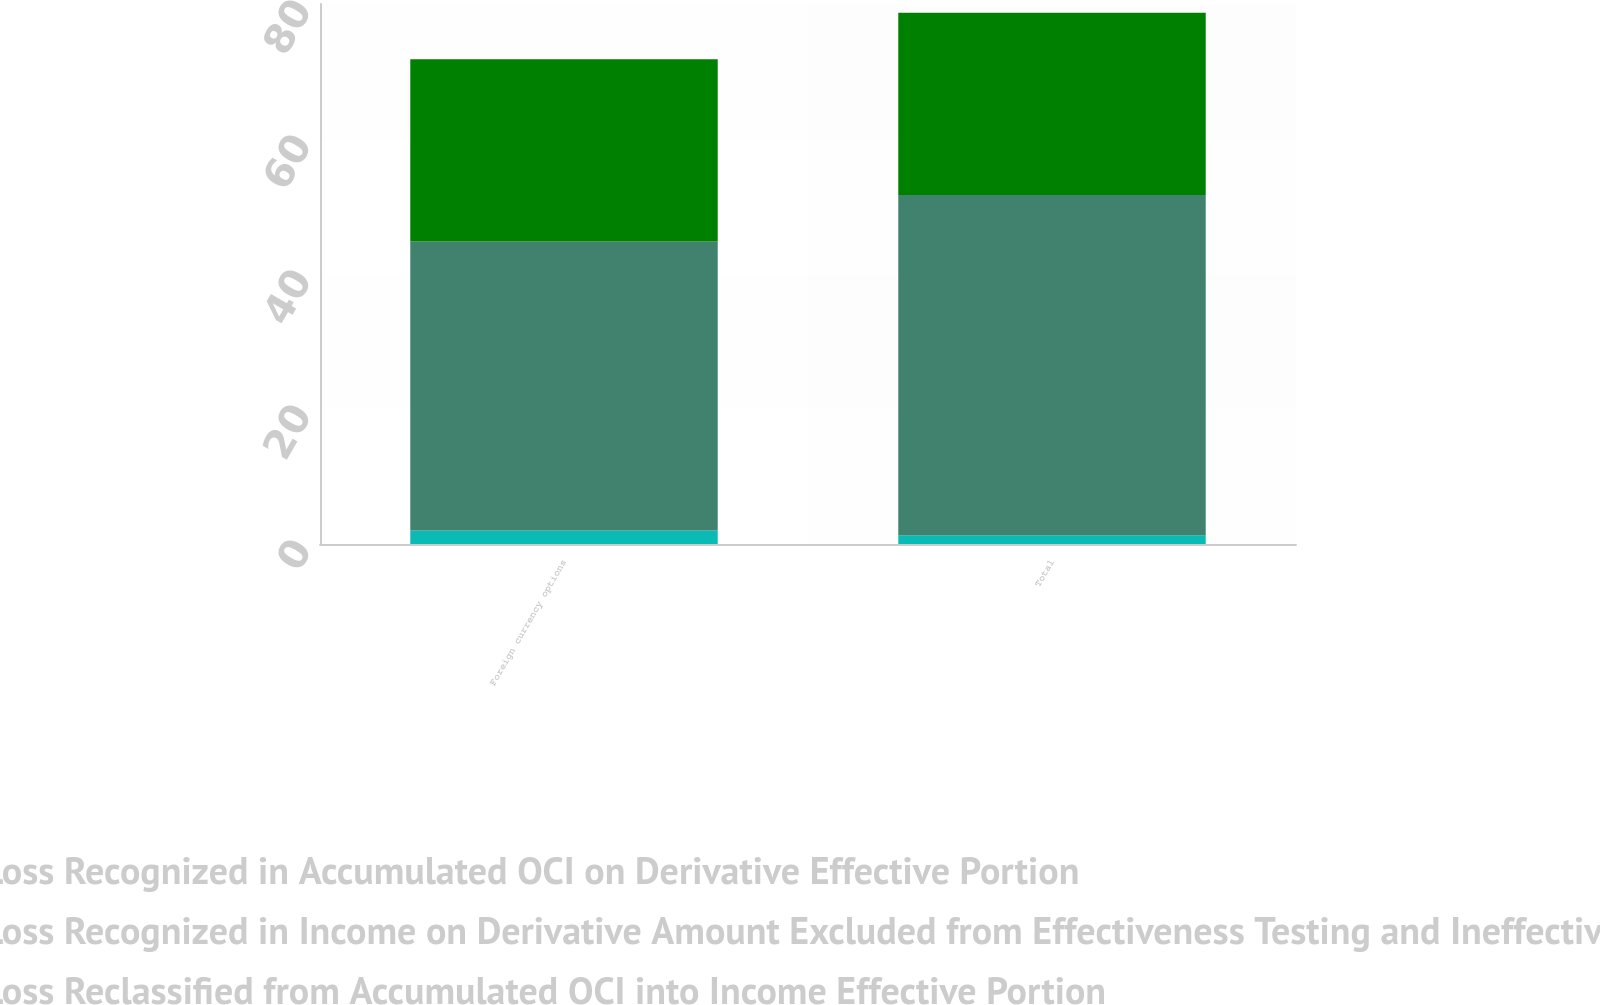Convert chart to OTSL. <chart><loc_0><loc_0><loc_500><loc_500><stacked_bar_chart><ecel><fcel>Foreign currency options<fcel>Total<nl><fcel>Gain Loss Recognized in Accumulated OCI on Derivative Effective Portion<fcel>2<fcel>1.3<nl><fcel>Gain Loss Recognized in Income on Derivative Amount Excluded from Effectiveness Testing and Ineffective Portion<fcel>42.8<fcel>50.4<nl><fcel>Gain Loss Reclassified from Accumulated OCI into Income Effective Portion<fcel>27<fcel>27<nl></chart> 